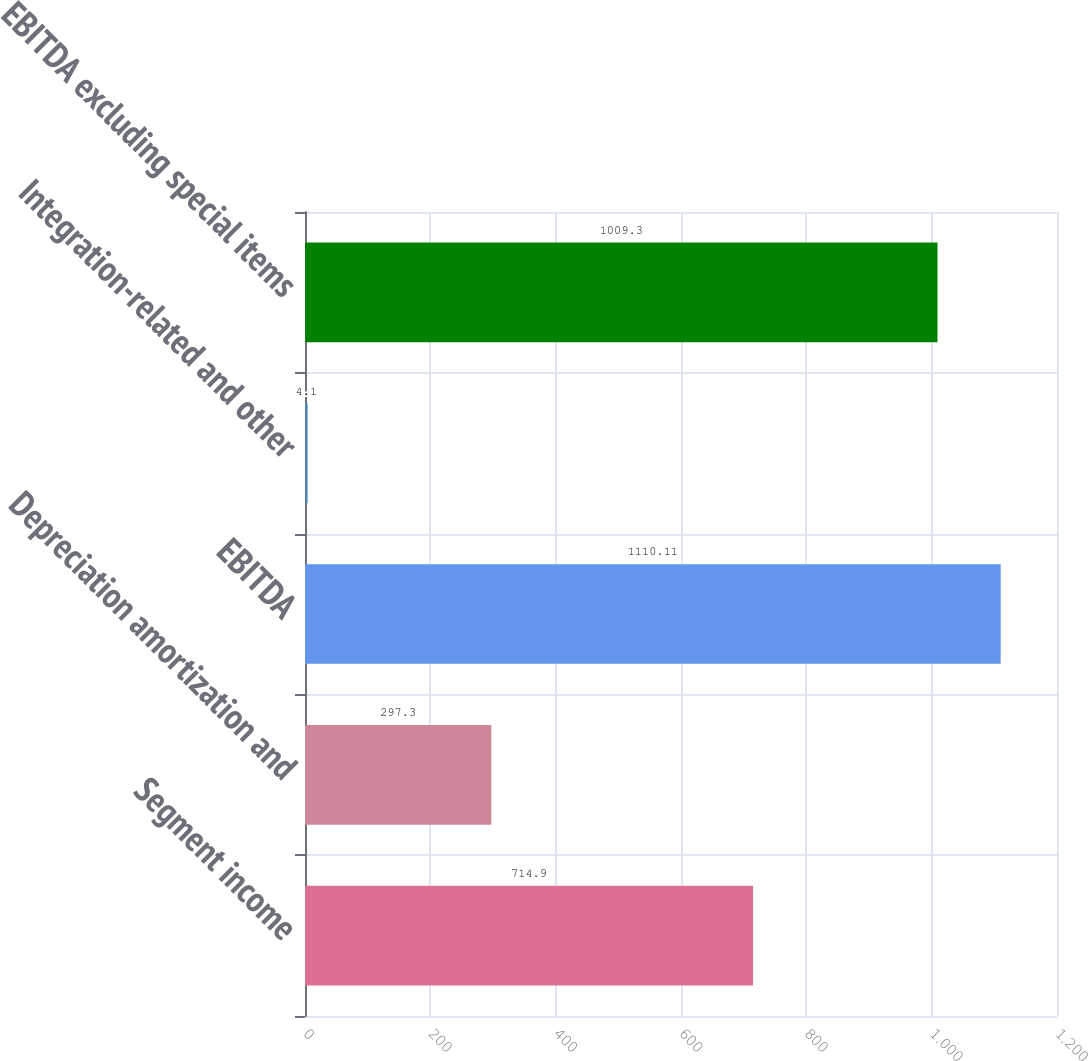Convert chart to OTSL. <chart><loc_0><loc_0><loc_500><loc_500><bar_chart><fcel>Segment income<fcel>Depreciation amortization and<fcel>EBITDA<fcel>Integration-related and other<fcel>EBITDA excluding special items<nl><fcel>714.9<fcel>297.3<fcel>1110.11<fcel>4.1<fcel>1009.3<nl></chart> 